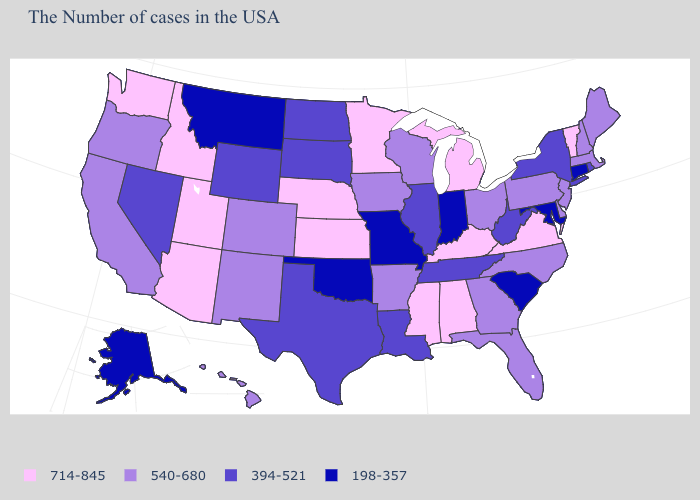What is the value of Kansas?
Concise answer only. 714-845. Name the states that have a value in the range 540-680?
Keep it brief. Maine, Massachusetts, New Hampshire, New Jersey, Delaware, Pennsylvania, North Carolina, Ohio, Florida, Georgia, Wisconsin, Arkansas, Iowa, Colorado, New Mexico, California, Oregon, Hawaii. Which states have the highest value in the USA?
Short answer required. Vermont, Virginia, Michigan, Kentucky, Alabama, Mississippi, Minnesota, Kansas, Nebraska, Utah, Arizona, Idaho, Washington. What is the value of South Carolina?
Be succinct. 198-357. Which states have the highest value in the USA?
Be succinct. Vermont, Virginia, Michigan, Kentucky, Alabama, Mississippi, Minnesota, Kansas, Nebraska, Utah, Arizona, Idaho, Washington. Does the map have missing data?
Quick response, please. No. Which states hav the highest value in the South?
Concise answer only. Virginia, Kentucky, Alabama, Mississippi. Among the states that border New Hampshire , does Massachusetts have the highest value?
Write a very short answer. No. Name the states that have a value in the range 394-521?
Be succinct. Rhode Island, New York, West Virginia, Tennessee, Illinois, Louisiana, Texas, South Dakota, North Dakota, Wyoming, Nevada. What is the value of Tennessee?
Concise answer only. 394-521. What is the value of Minnesota?
Quick response, please. 714-845. Name the states that have a value in the range 540-680?
Quick response, please. Maine, Massachusetts, New Hampshire, New Jersey, Delaware, Pennsylvania, North Carolina, Ohio, Florida, Georgia, Wisconsin, Arkansas, Iowa, Colorado, New Mexico, California, Oregon, Hawaii. Name the states that have a value in the range 714-845?
Give a very brief answer. Vermont, Virginia, Michigan, Kentucky, Alabama, Mississippi, Minnesota, Kansas, Nebraska, Utah, Arizona, Idaho, Washington. What is the value of Connecticut?
Answer briefly. 198-357. Name the states that have a value in the range 198-357?
Keep it brief. Connecticut, Maryland, South Carolina, Indiana, Missouri, Oklahoma, Montana, Alaska. 